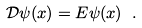Convert formula to latex. <formula><loc_0><loc_0><loc_500><loc_500>\mathcal { D } \psi ( x ) = E \psi ( x ) \ .</formula> 